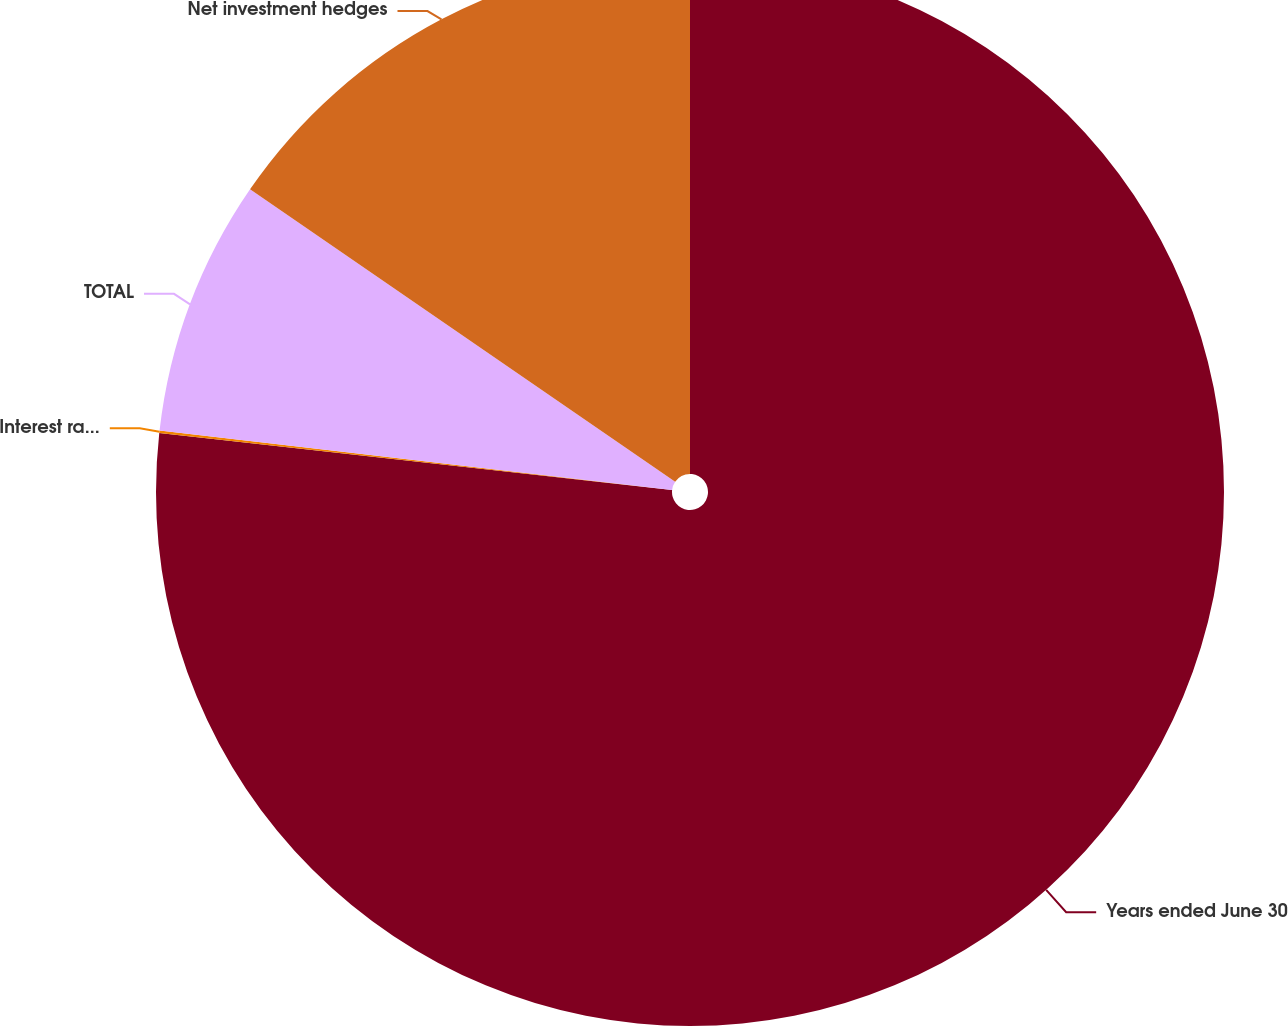Convert chart to OTSL. <chart><loc_0><loc_0><loc_500><loc_500><pie_chart><fcel>Years ended June 30<fcel>Interest rate contracts<fcel>TOTAL<fcel>Net investment hedges<nl><fcel>76.76%<fcel>0.08%<fcel>7.75%<fcel>15.41%<nl></chart> 